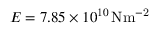<formula> <loc_0><loc_0><loc_500><loc_500>E = 7 . 8 5 \times 1 0 ^ { 1 0 } \, { N m ^ { - 2 } }</formula> 